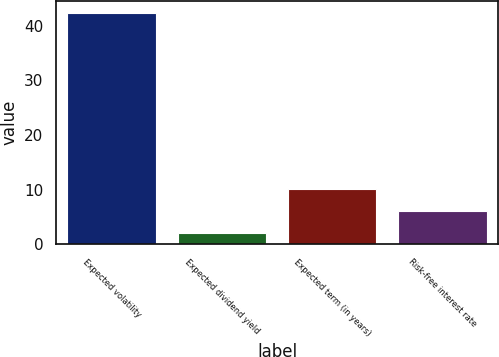<chart> <loc_0><loc_0><loc_500><loc_500><bar_chart><fcel>Expected volatility<fcel>Expected dividend yield<fcel>Expected term (in years)<fcel>Risk-free interest rate<nl><fcel>42.4<fcel>2.01<fcel>10.09<fcel>6.05<nl></chart> 